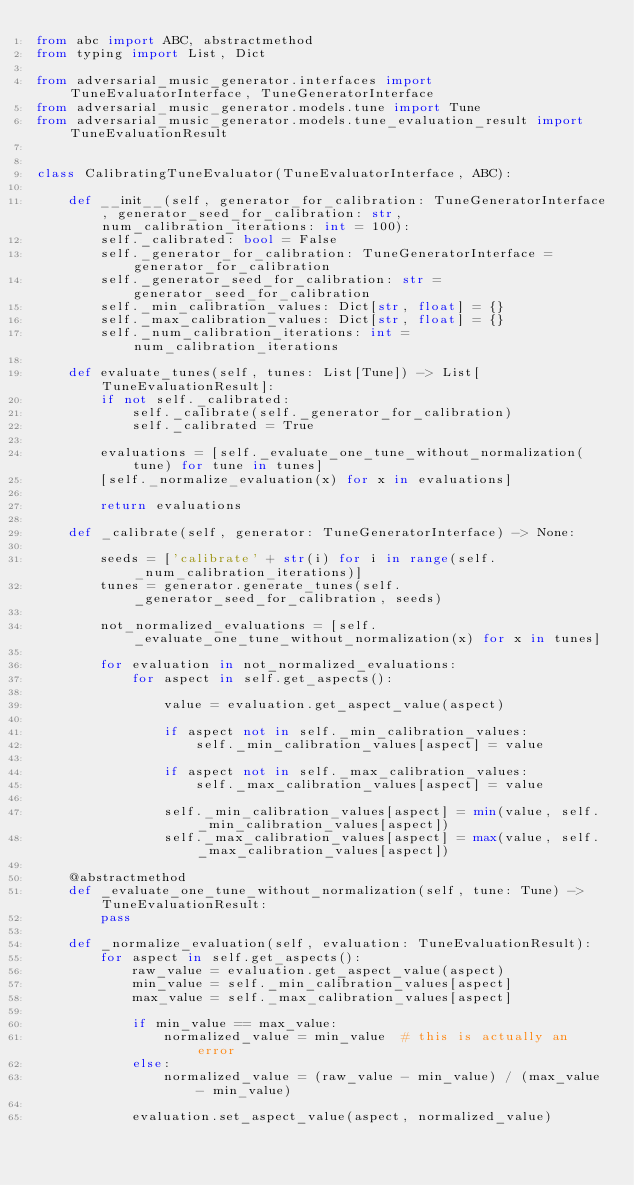<code> <loc_0><loc_0><loc_500><loc_500><_Python_>from abc import ABC, abstractmethod
from typing import List, Dict

from adversarial_music_generator.interfaces import TuneEvaluatorInterface, TuneGeneratorInterface
from adversarial_music_generator.models.tune import Tune
from adversarial_music_generator.models.tune_evaluation_result import TuneEvaluationResult


class CalibratingTuneEvaluator(TuneEvaluatorInterface, ABC):

    def __init__(self, generator_for_calibration: TuneGeneratorInterface, generator_seed_for_calibration: str, num_calibration_iterations: int = 100):
        self._calibrated: bool = False
        self._generator_for_calibration: TuneGeneratorInterface = generator_for_calibration
        self._generator_seed_for_calibration: str = generator_seed_for_calibration
        self._min_calibration_values: Dict[str, float] = {}
        self._max_calibration_values: Dict[str, float] = {}
        self._num_calibration_iterations: int = num_calibration_iterations

    def evaluate_tunes(self, tunes: List[Tune]) -> List[TuneEvaluationResult]:
        if not self._calibrated:
            self._calibrate(self._generator_for_calibration)
            self._calibrated = True

        evaluations = [self._evaluate_one_tune_without_normalization(tune) for tune in tunes]
        [self._normalize_evaluation(x) for x in evaluations]

        return evaluations

    def _calibrate(self, generator: TuneGeneratorInterface) -> None:

        seeds = ['calibrate' + str(i) for i in range(self._num_calibration_iterations)]
        tunes = generator.generate_tunes(self._generator_seed_for_calibration, seeds)

        not_normalized_evaluations = [self._evaluate_one_tune_without_normalization(x) for x in tunes]

        for evaluation in not_normalized_evaluations:
            for aspect in self.get_aspects():

                value = evaluation.get_aspect_value(aspect)

                if aspect not in self._min_calibration_values:
                    self._min_calibration_values[aspect] = value

                if aspect not in self._max_calibration_values:
                    self._max_calibration_values[aspect] = value

                self._min_calibration_values[aspect] = min(value, self._min_calibration_values[aspect])
                self._max_calibration_values[aspect] = max(value, self._max_calibration_values[aspect])

    @abstractmethod
    def _evaluate_one_tune_without_normalization(self, tune: Tune) -> TuneEvaluationResult:
        pass

    def _normalize_evaluation(self, evaluation: TuneEvaluationResult):
        for aspect in self.get_aspects():
            raw_value = evaluation.get_aspect_value(aspect)
            min_value = self._min_calibration_values[aspect]
            max_value = self._max_calibration_values[aspect]

            if min_value == max_value:
                normalized_value = min_value  # this is actually an error
            else:
                normalized_value = (raw_value - min_value) / (max_value - min_value)

            evaluation.set_aspect_value(aspect, normalized_value)
</code> 